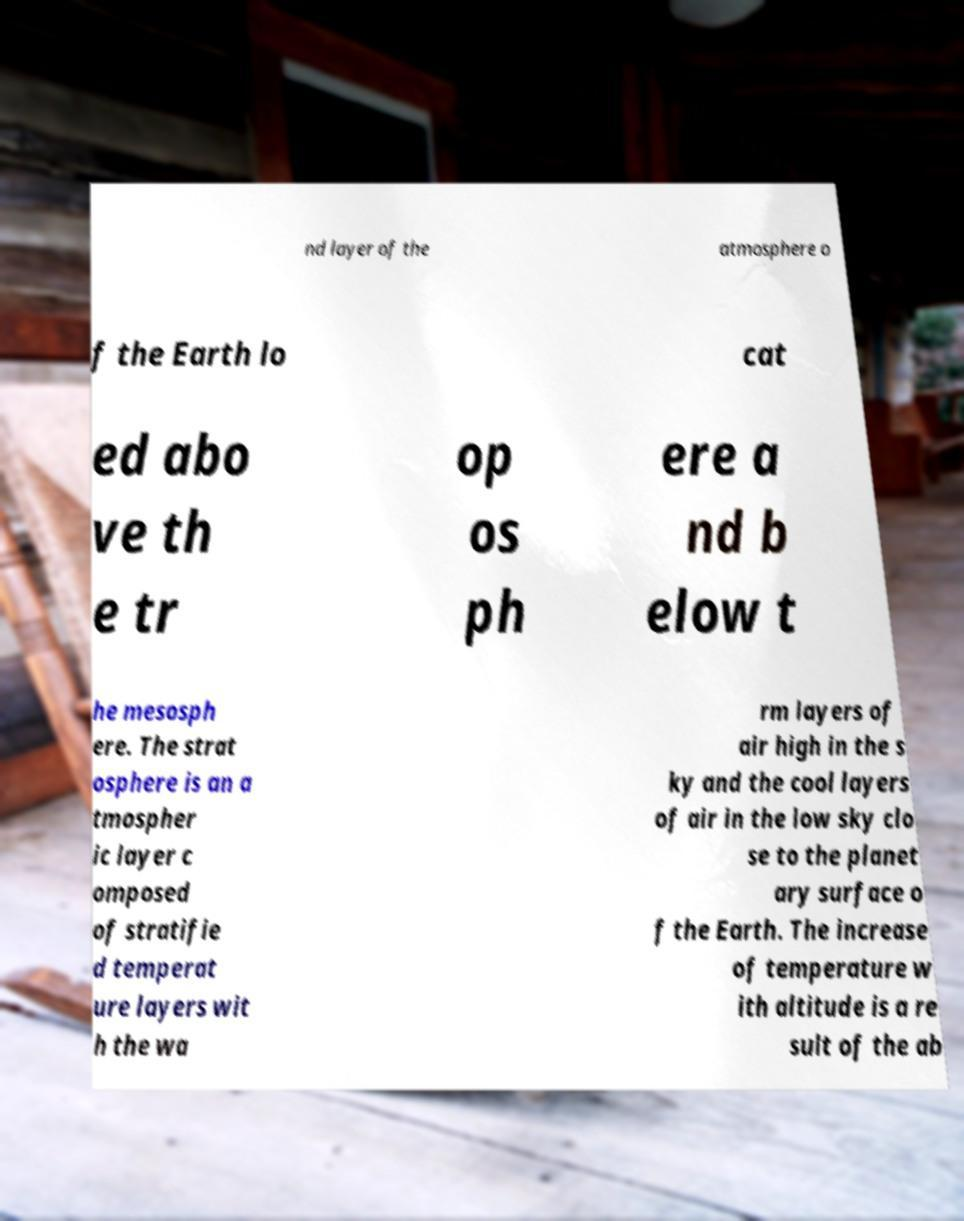There's text embedded in this image that I need extracted. Can you transcribe it verbatim? nd layer of the atmosphere o f the Earth lo cat ed abo ve th e tr op os ph ere a nd b elow t he mesosph ere. The strat osphere is an a tmospher ic layer c omposed of stratifie d temperat ure layers wit h the wa rm layers of air high in the s ky and the cool layers of air in the low sky clo se to the planet ary surface o f the Earth. The increase of temperature w ith altitude is a re sult of the ab 